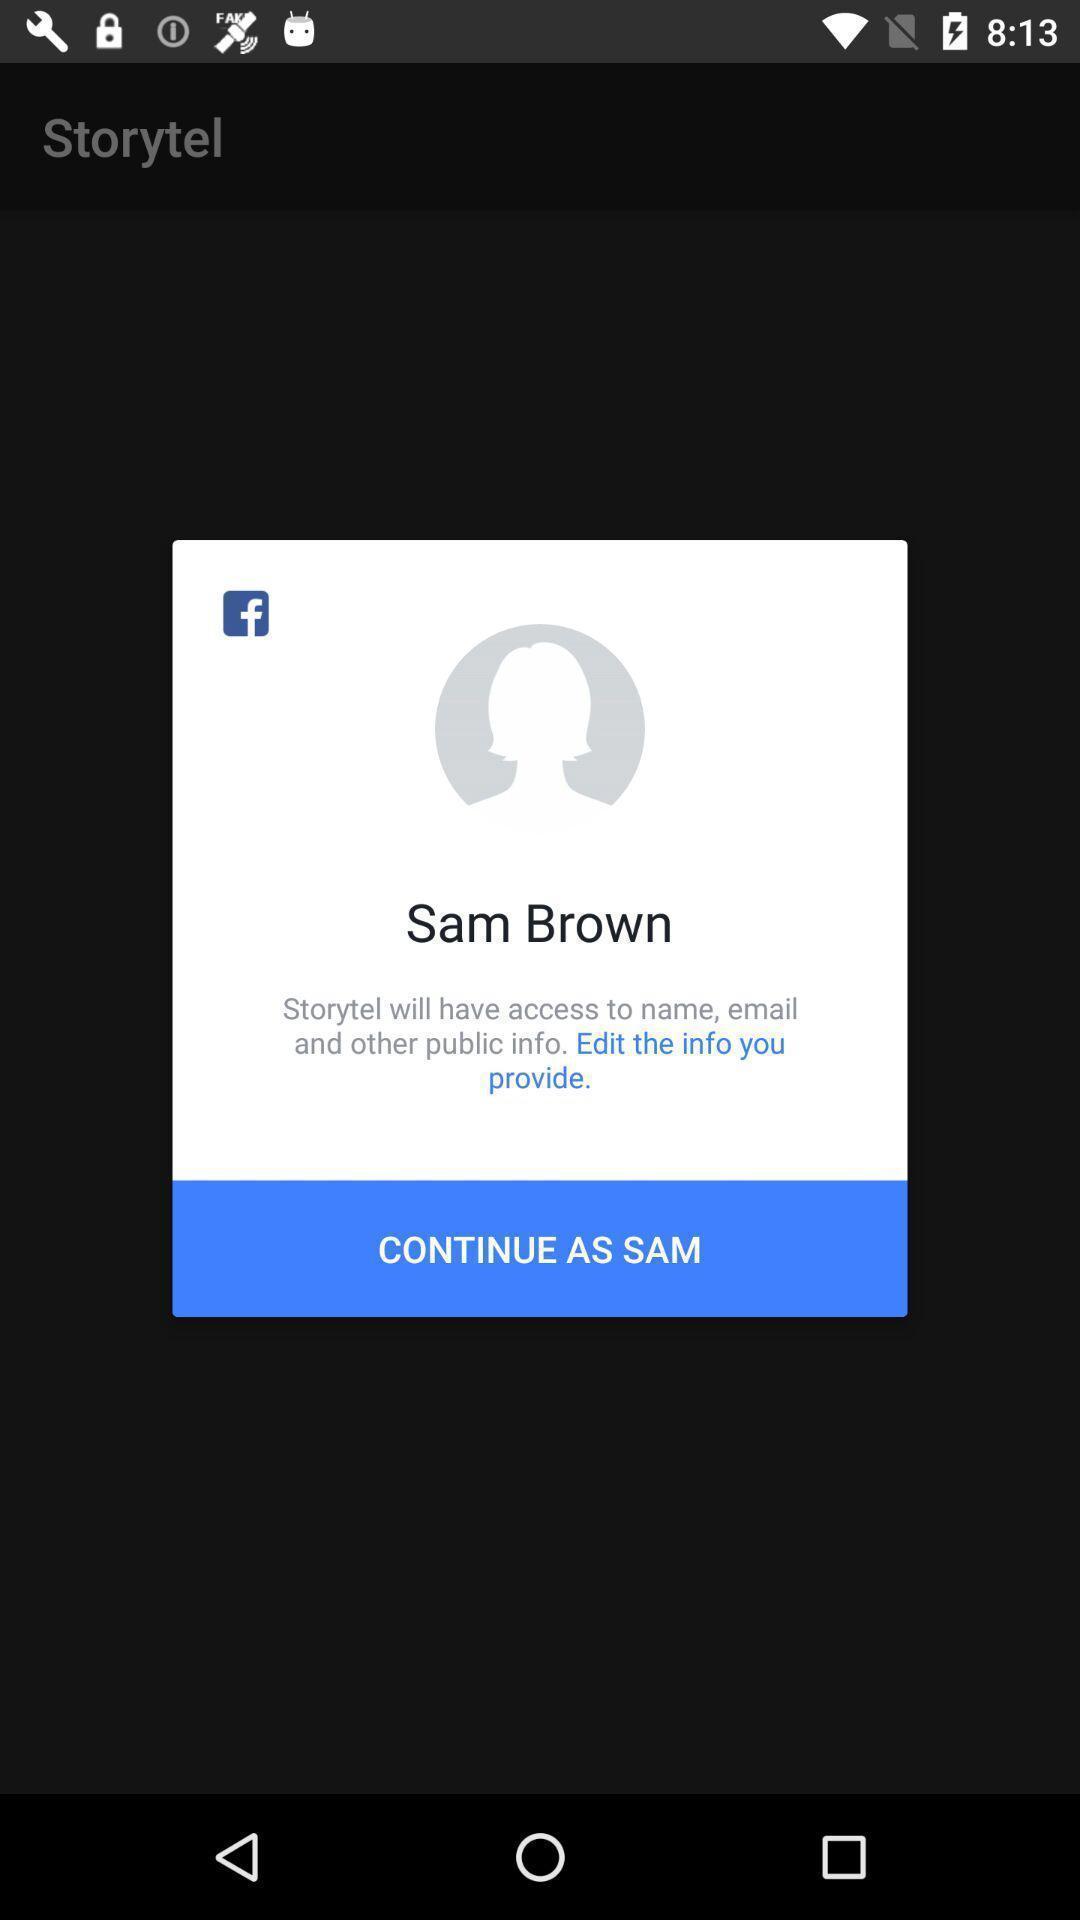Describe the content in this image. Pop-up showing information about social media profile. 